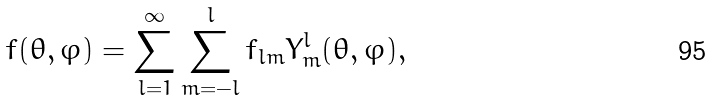Convert formula to latex. <formula><loc_0><loc_0><loc_500><loc_500>f ( \theta , \varphi ) = \sum _ { l = 1 } ^ { \infty } \sum _ { m = - l } ^ { l } f _ { l m } Y _ { m } ^ { l } ( \theta , \varphi ) ,</formula> 